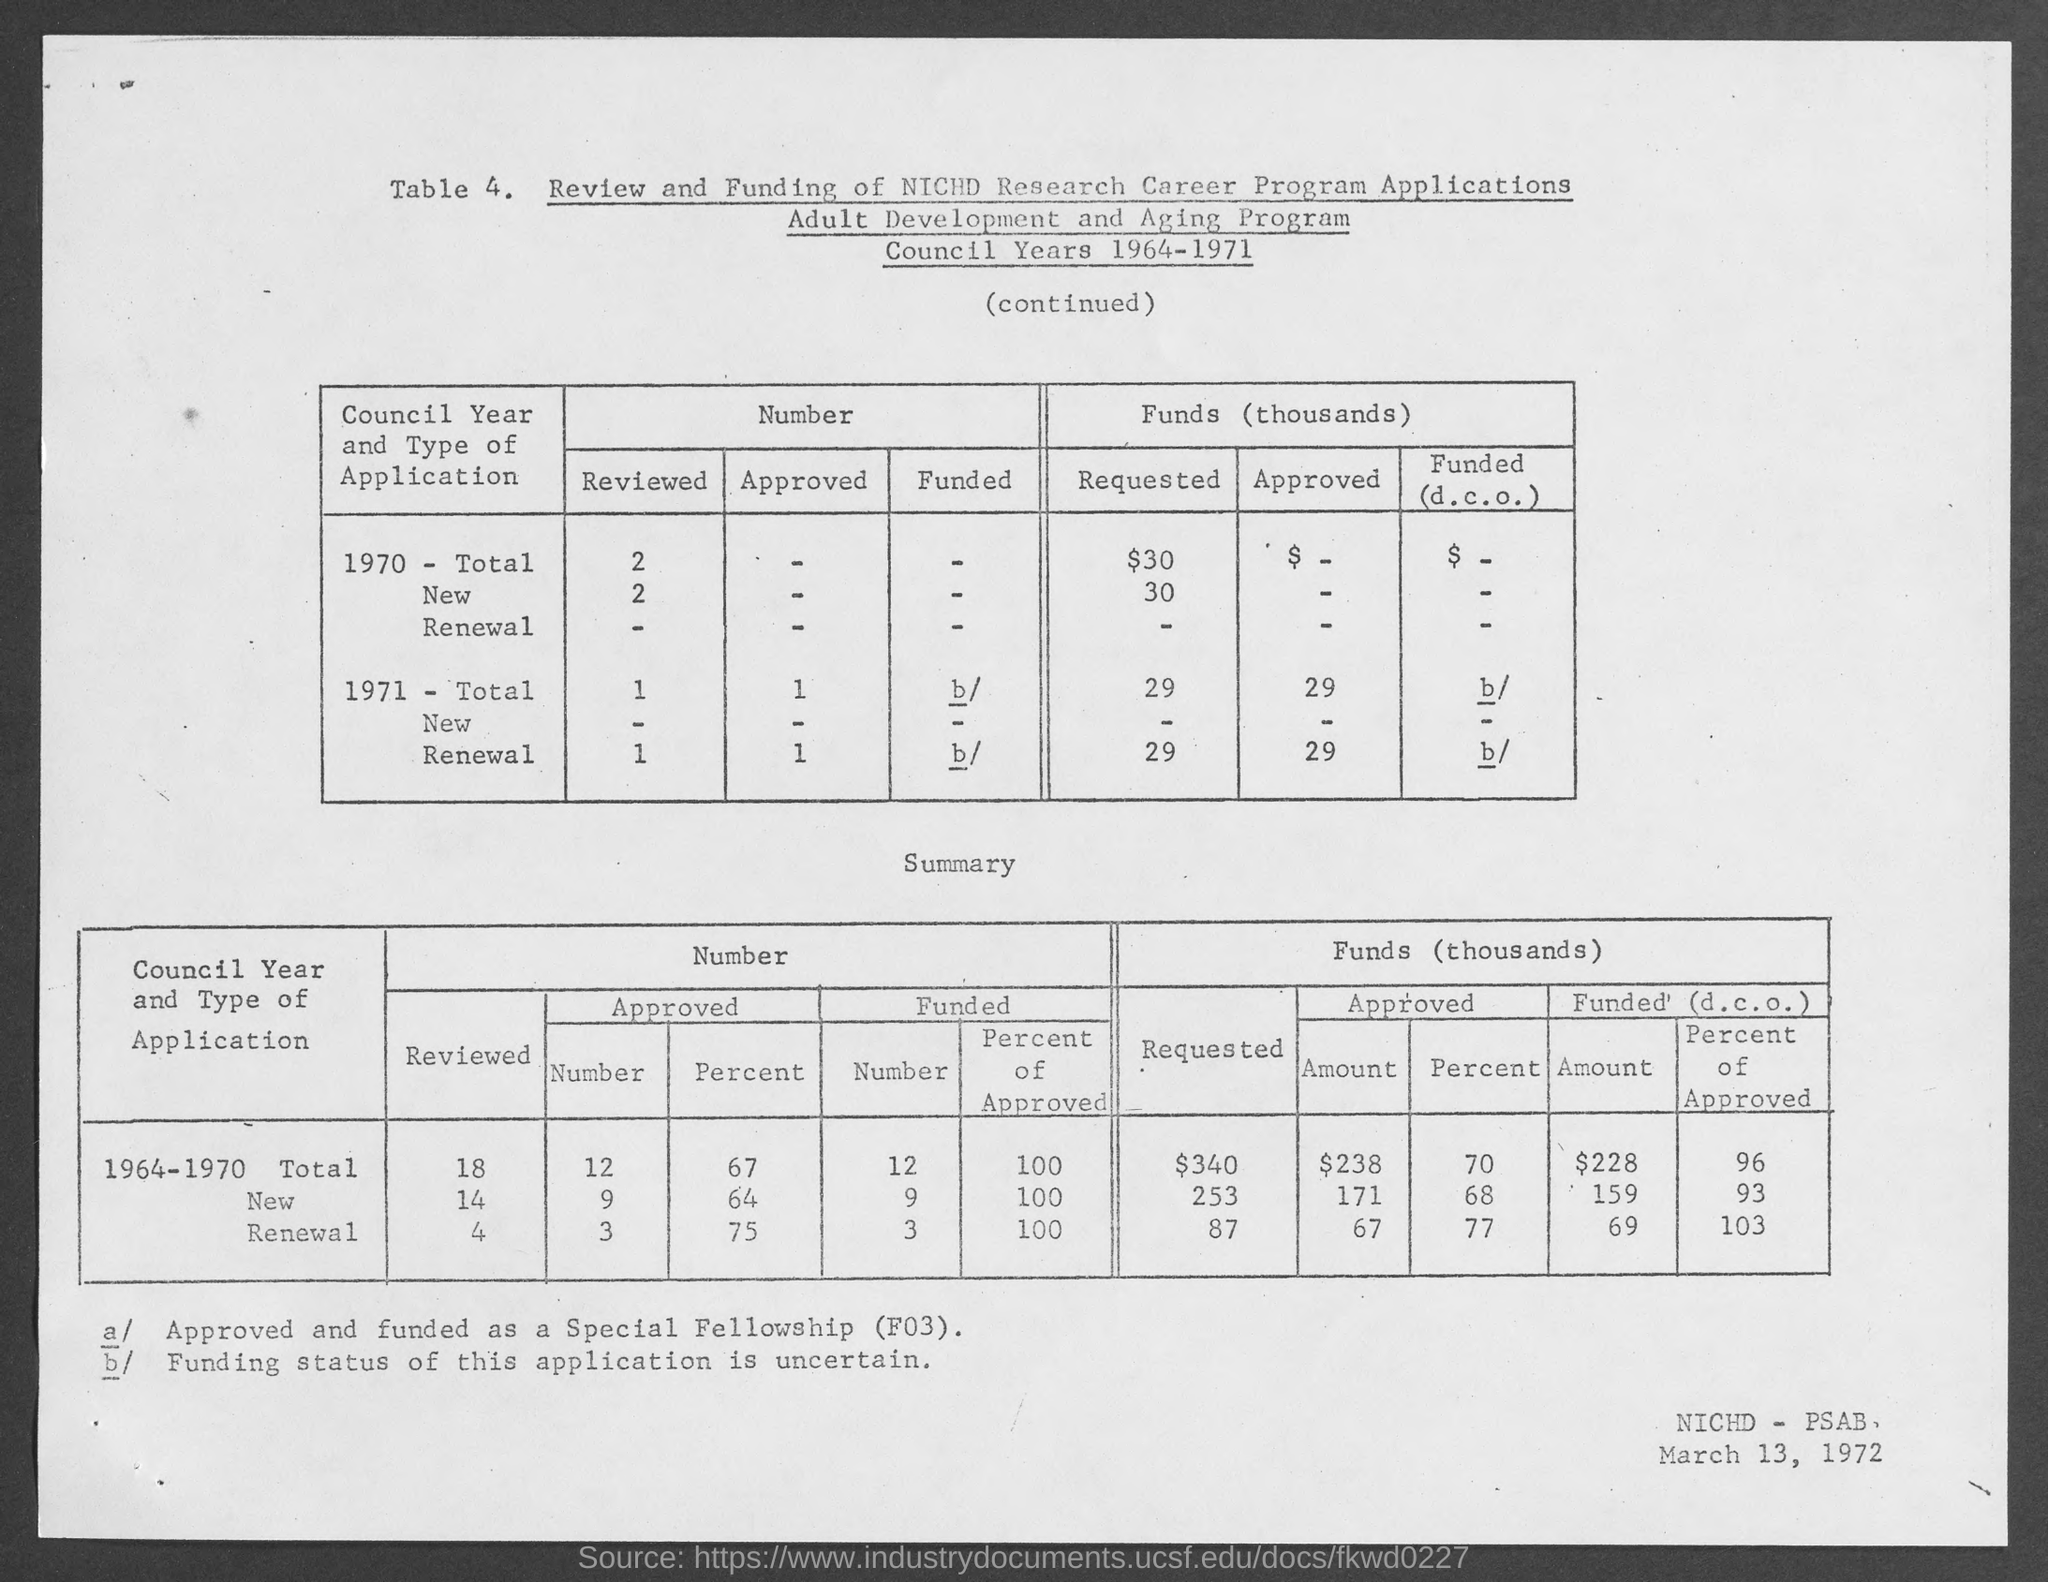Point out several critical features in this image. The date in the bottom-right corner of the page is March 13, 1972. 